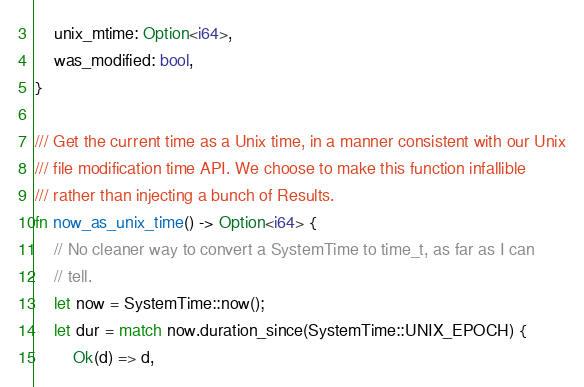Convert code to text. <code><loc_0><loc_0><loc_500><loc_500><_Rust_>    unix_mtime: Option<i64>,
    was_modified: bool,
}

/// Get the current time as a Unix time, in a manner consistent with our Unix
/// file modification time API. We choose to make this function infallible
/// rather than injecting a bunch of Results.
fn now_as_unix_time() -> Option<i64> {
    // No cleaner way to convert a SystemTime to time_t, as far as I can
    // tell.
    let now = SystemTime::now();
    let dur = match now.duration_since(SystemTime::UNIX_EPOCH) {
        Ok(d) => d,</code> 